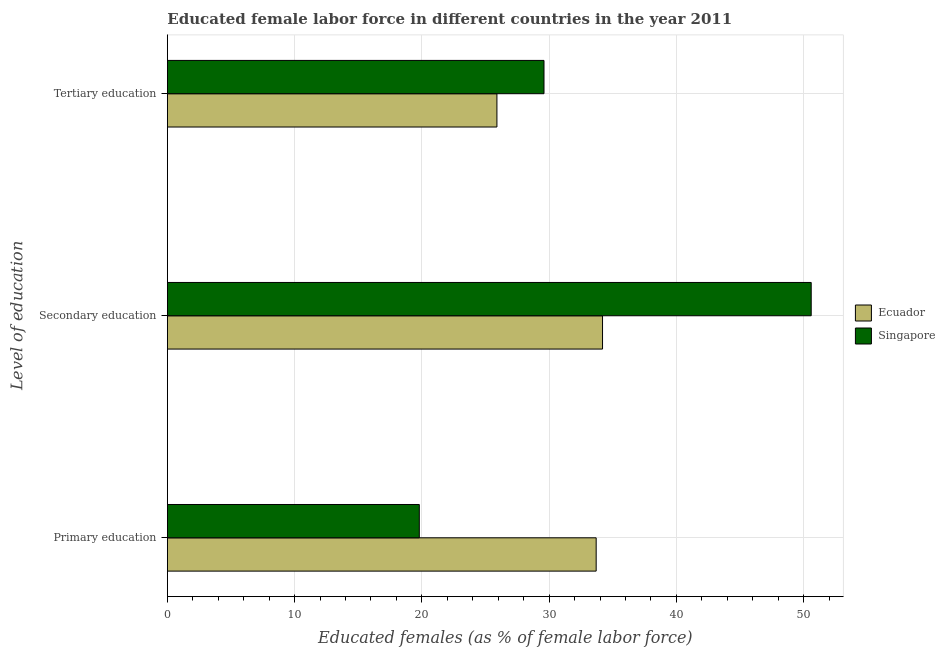How many groups of bars are there?
Ensure brevity in your answer.  3. Are the number of bars per tick equal to the number of legend labels?
Offer a very short reply. Yes. Are the number of bars on each tick of the Y-axis equal?
Provide a short and direct response. Yes. How many bars are there on the 2nd tick from the top?
Your response must be concise. 2. What is the percentage of female labor force who received secondary education in Singapore?
Your answer should be very brief. 50.6. Across all countries, what is the maximum percentage of female labor force who received tertiary education?
Make the answer very short. 29.6. Across all countries, what is the minimum percentage of female labor force who received primary education?
Give a very brief answer. 19.8. In which country was the percentage of female labor force who received primary education maximum?
Your response must be concise. Ecuador. In which country was the percentage of female labor force who received tertiary education minimum?
Your answer should be compact. Ecuador. What is the total percentage of female labor force who received secondary education in the graph?
Keep it short and to the point. 84.8. What is the difference between the percentage of female labor force who received secondary education in Ecuador and that in Singapore?
Ensure brevity in your answer.  -16.4. What is the difference between the percentage of female labor force who received secondary education in Singapore and the percentage of female labor force who received primary education in Ecuador?
Ensure brevity in your answer.  16.9. What is the average percentage of female labor force who received secondary education per country?
Provide a succinct answer. 42.4. What is the difference between the percentage of female labor force who received tertiary education and percentage of female labor force who received primary education in Singapore?
Your answer should be compact. 9.8. In how many countries, is the percentage of female labor force who received tertiary education greater than 38 %?
Your answer should be very brief. 0. What is the ratio of the percentage of female labor force who received primary education in Ecuador to that in Singapore?
Give a very brief answer. 1.7. What is the difference between the highest and the second highest percentage of female labor force who received tertiary education?
Offer a very short reply. 3.7. What is the difference between the highest and the lowest percentage of female labor force who received primary education?
Offer a very short reply. 13.9. In how many countries, is the percentage of female labor force who received tertiary education greater than the average percentage of female labor force who received tertiary education taken over all countries?
Your response must be concise. 1. What does the 1st bar from the top in Primary education represents?
Offer a terse response. Singapore. What does the 1st bar from the bottom in Tertiary education represents?
Keep it short and to the point. Ecuador. How many bars are there?
Provide a short and direct response. 6. Are the values on the major ticks of X-axis written in scientific E-notation?
Your answer should be very brief. No. Does the graph contain any zero values?
Ensure brevity in your answer.  No. Does the graph contain grids?
Offer a terse response. Yes. Where does the legend appear in the graph?
Offer a terse response. Center right. What is the title of the graph?
Provide a short and direct response. Educated female labor force in different countries in the year 2011. What is the label or title of the X-axis?
Give a very brief answer. Educated females (as % of female labor force). What is the label or title of the Y-axis?
Keep it short and to the point. Level of education. What is the Educated females (as % of female labor force) in Ecuador in Primary education?
Make the answer very short. 33.7. What is the Educated females (as % of female labor force) of Singapore in Primary education?
Your answer should be very brief. 19.8. What is the Educated females (as % of female labor force) of Ecuador in Secondary education?
Give a very brief answer. 34.2. What is the Educated females (as % of female labor force) in Singapore in Secondary education?
Offer a terse response. 50.6. What is the Educated females (as % of female labor force) of Ecuador in Tertiary education?
Provide a succinct answer. 25.9. What is the Educated females (as % of female labor force) of Singapore in Tertiary education?
Provide a succinct answer. 29.6. Across all Level of education, what is the maximum Educated females (as % of female labor force) of Ecuador?
Offer a terse response. 34.2. Across all Level of education, what is the maximum Educated females (as % of female labor force) in Singapore?
Offer a terse response. 50.6. Across all Level of education, what is the minimum Educated females (as % of female labor force) in Ecuador?
Your response must be concise. 25.9. Across all Level of education, what is the minimum Educated females (as % of female labor force) of Singapore?
Your answer should be compact. 19.8. What is the total Educated females (as % of female labor force) in Ecuador in the graph?
Your answer should be compact. 93.8. What is the total Educated females (as % of female labor force) in Singapore in the graph?
Offer a terse response. 100. What is the difference between the Educated females (as % of female labor force) in Ecuador in Primary education and that in Secondary education?
Your answer should be very brief. -0.5. What is the difference between the Educated females (as % of female labor force) in Singapore in Primary education and that in Secondary education?
Your response must be concise. -30.8. What is the difference between the Educated females (as % of female labor force) in Singapore in Primary education and that in Tertiary education?
Give a very brief answer. -9.8. What is the difference between the Educated females (as % of female labor force) of Ecuador in Secondary education and that in Tertiary education?
Your answer should be very brief. 8.3. What is the difference between the Educated females (as % of female labor force) in Singapore in Secondary education and that in Tertiary education?
Ensure brevity in your answer.  21. What is the difference between the Educated females (as % of female labor force) in Ecuador in Primary education and the Educated females (as % of female labor force) in Singapore in Secondary education?
Provide a short and direct response. -16.9. What is the average Educated females (as % of female labor force) in Ecuador per Level of education?
Your response must be concise. 31.27. What is the average Educated females (as % of female labor force) of Singapore per Level of education?
Provide a short and direct response. 33.33. What is the difference between the Educated females (as % of female labor force) in Ecuador and Educated females (as % of female labor force) in Singapore in Secondary education?
Give a very brief answer. -16.4. What is the ratio of the Educated females (as % of female labor force) of Ecuador in Primary education to that in Secondary education?
Your answer should be very brief. 0.99. What is the ratio of the Educated females (as % of female labor force) in Singapore in Primary education to that in Secondary education?
Make the answer very short. 0.39. What is the ratio of the Educated females (as % of female labor force) of Ecuador in Primary education to that in Tertiary education?
Your answer should be very brief. 1.3. What is the ratio of the Educated females (as % of female labor force) in Singapore in Primary education to that in Tertiary education?
Your answer should be compact. 0.67. What is the ratio of the Educated females (as % of female labor force) in Ecuador in Secondary education to that in Tertiary education?
Provide a short and direct response. 1.32. What is the ratio of the Educated females (as % of female labor force) of Singapore in Secondary education to that in Tertiary education?
Offer a terse response. 1.71. What is the difference between the highest and the second highest Educated females (as % of female labor force) of Ecuador?
Your answer should be compact. 0.5. What is the difference between the highest and the second highest Educated females (as % of female labor force) of Singapore?
Ensure brevity in your answer.  21. What is the difference between the highest and the lowest Educated females (as % of female labor force) in Singapore?
Your answer should be compact. 30.8. 